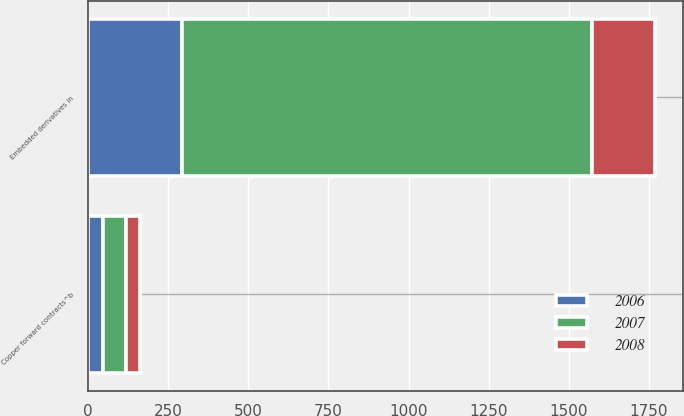Convert chart. <chart><loc_0><loc_0><loc_500><loc_500><stacked_bar_chart><ecel><fcel>Embedded derivatives in<fcel>Copper forward contracts^b<nl><fcel>2007<fcel>1278<fcel>71<nl><fcel>2008<fcel>197<fcel>44<nl><fcel>2006<fcel>293<fcel>47<nl></chart> 